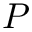<formula> <loc_0><loc_0><loc_500><loc_500>P</formula> 